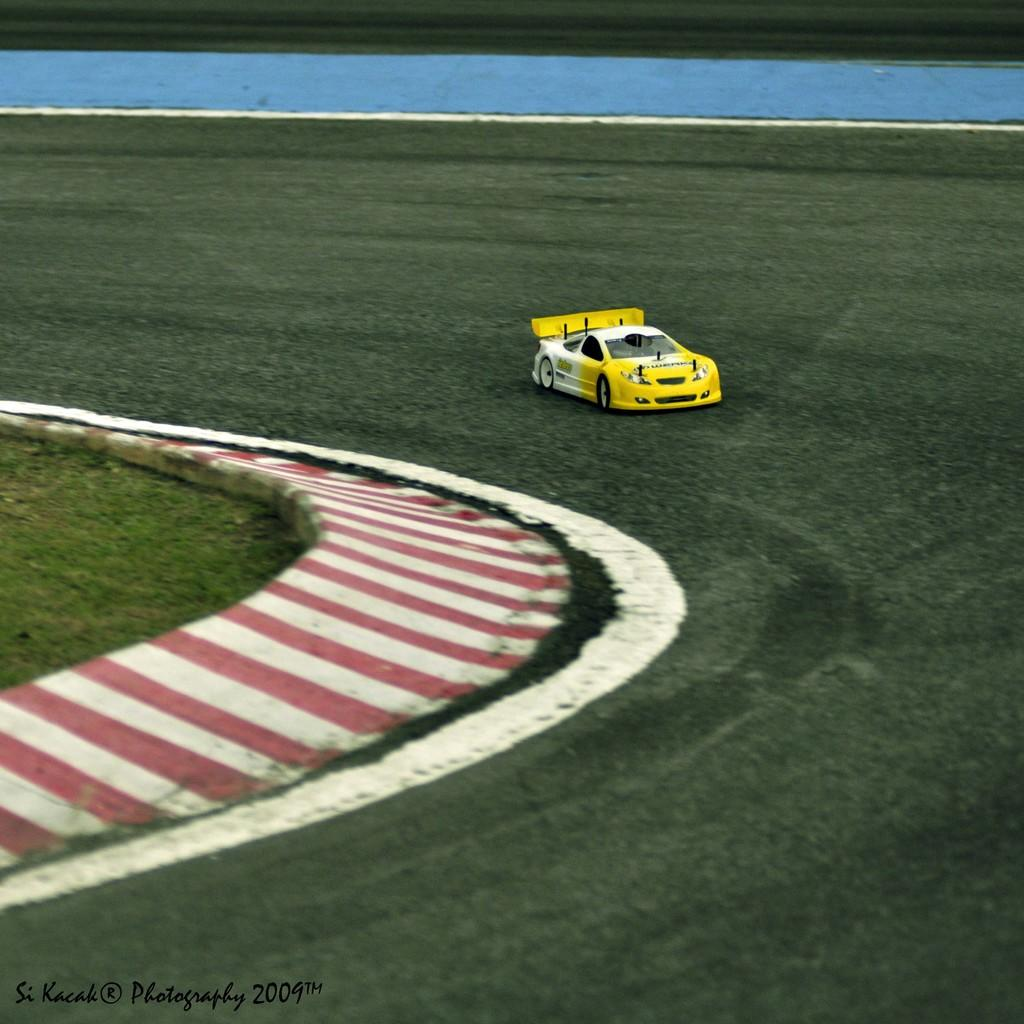What is the main subject of the image? There is a vehicle on the road in the image. What type of natural environment can be seen in the image? There is grass visible in the image. Is there any text present in the image? Yes, there is text at the bottom of the image. What type of badge can be seen on the vehicle in the image? There is no badge visible on the vehicle in the image. What part of the vehicle is inflated with air in the image? There is no part of the vehicle that is inflated with air in the image. 